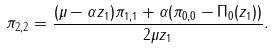Convert formula to latex. <formula><loc_0><loc_0><loc_500><loc_500>\pi _ { 2 , 2 } = \frac { ( \mu - \alpha z _ { 1 } ) \pi _ { 1 , 1 } + \alpha ( \pi _ { 0 , 0 } - \Pi _ { 0 } ( z _ { 1 } ) ) } { 2 \mu z _ { 1 } } .</formula> 